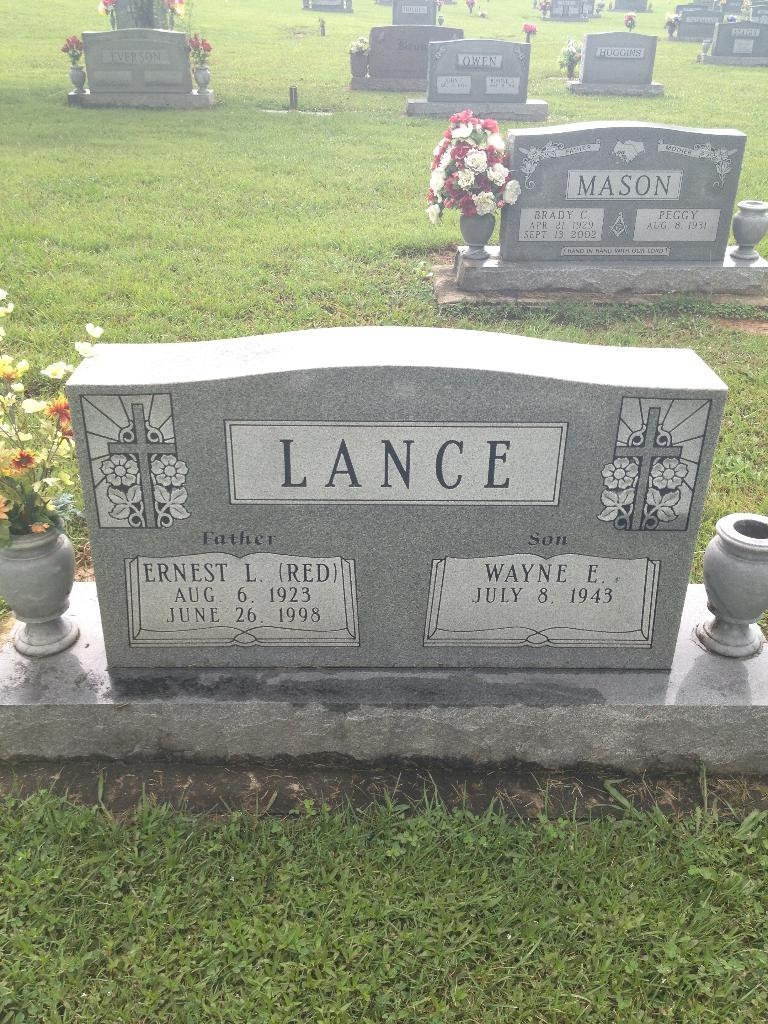What can be seen in the image? There are graves in the image. Where are the graves located? The graves are on a grassland. What song is the girl singing while wearing trousers in the image? There is no girl or song mentioned in the image; it only features graves on a grassland. 